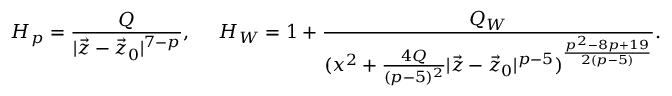<formula> <loc_0><loc_0><loc_500><loc_500>H _ { p } = { \frac { Q } { | \vec { z } - \vec { z } _ { 0 } | ^ { 7 - p } } } , \quad H _ { W } = 1 + { \frac { Q _ { W } } { ( x ^ { 2 } + { \frac { 4 Q } { ( p - 5 ) ^ { 2 } } } | \vec { z } - \vec { z } _ { 0 } | ^ { p - 5 } ) ^ { \frac { p ^ { 2 } - 8 p + 1 9 } { 2 ( p - 5 ) } } } } .</formula> 